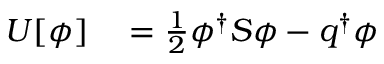<formula> <loc_0><loc_0><loc_500><loc_500>\begin{array} { r l } { U [ \phi ] } & = \frac { 1 } { 2 } \phi ^ { \dagger } S \phi - q ^ { \dagger } \phi } \end{array}</formula> 